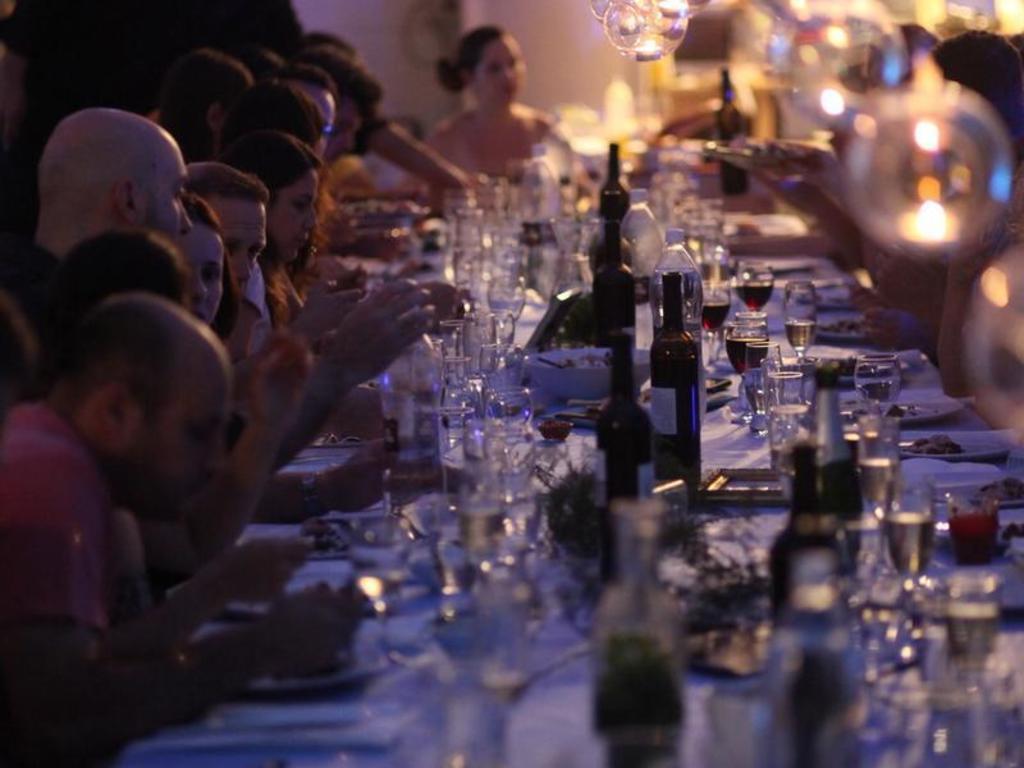How would you summarize this image in a sentence or two? In this image I can see a group of people are sitting on the chairs in front of a table on which I can see bottles, glasses and so on. In the background I can see lights and a wall. This image is taken may be in a hall. 